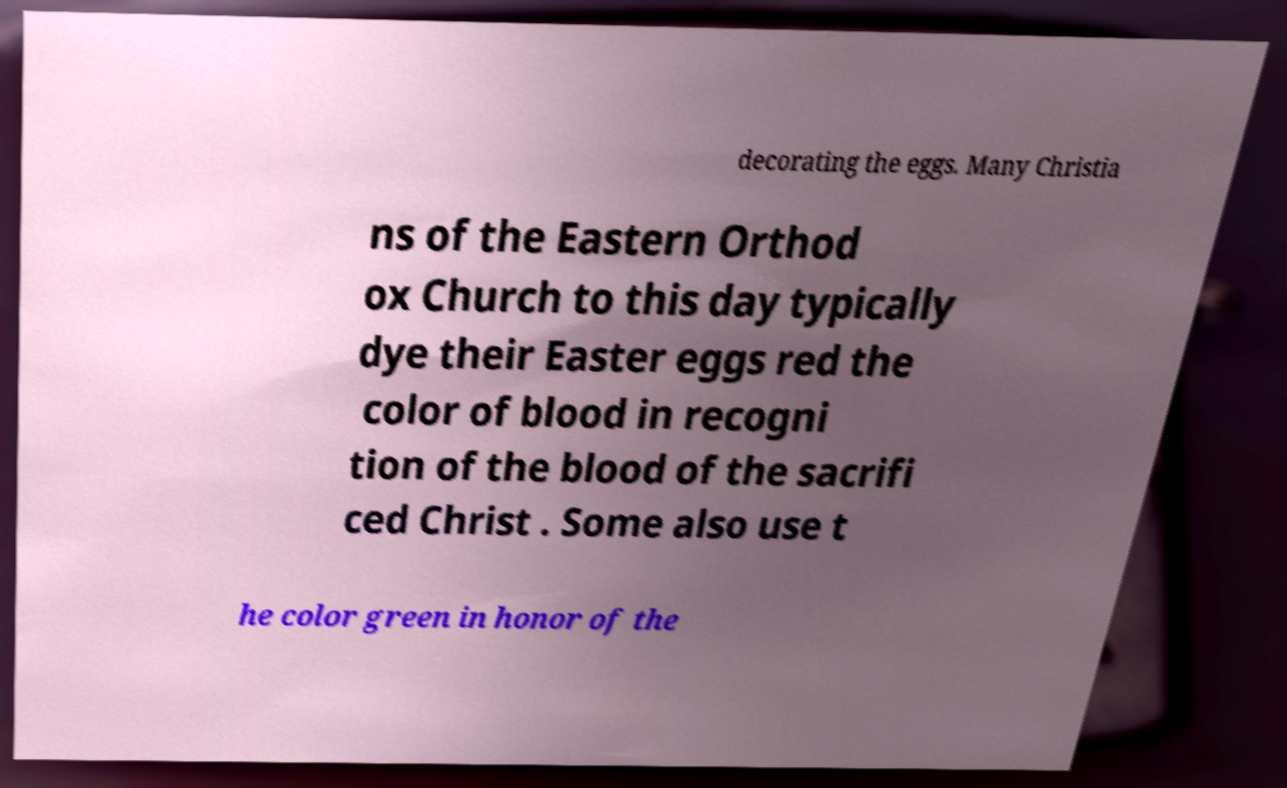Can you read and provide the text displayed in the image?This photo seems to have some interesting text. Can you extract and type it out for me? decorating the eggs. Many Christia ns of the Eastern Orthod ox Church to this day typically dye their Easter eggs red the color of blood in recogni tion of the blood of the sacrifi ced Christ . Some also use t he color green in honor of the 